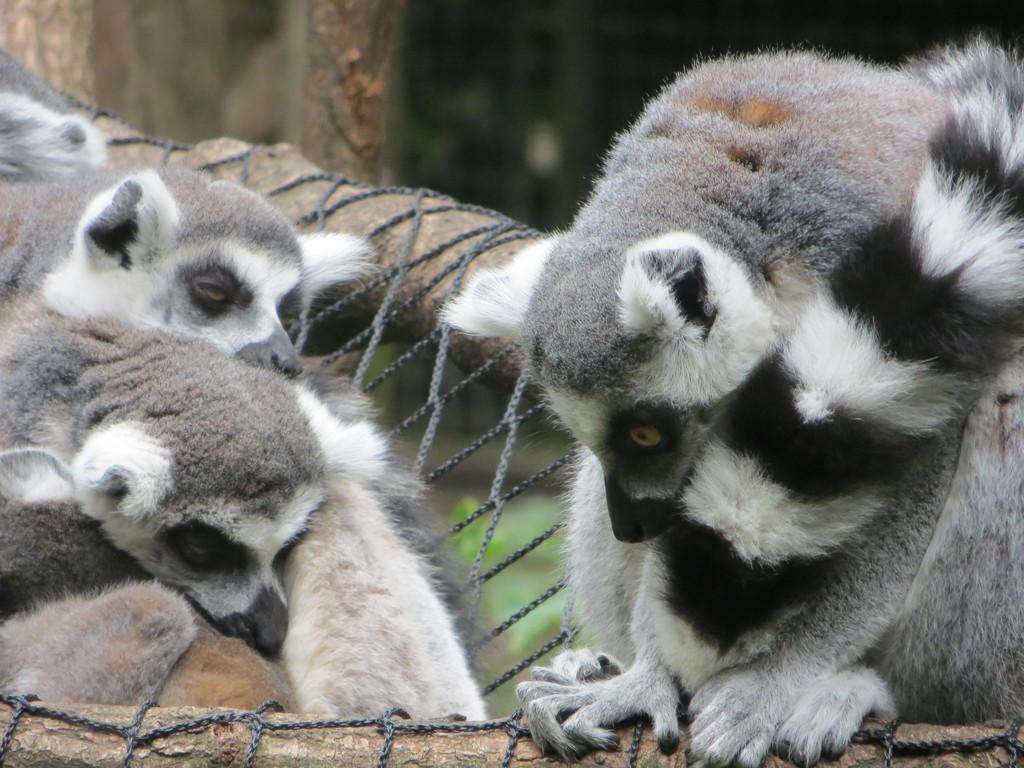Can you describe this image briefly? In this image in the front there are animals and the background is blurry and in the center there is a rope which is tied on a tree. 